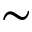Convert formula to latex. <formula><loc_0><loc_0><loc_500><loc_500>\sim</formula> 